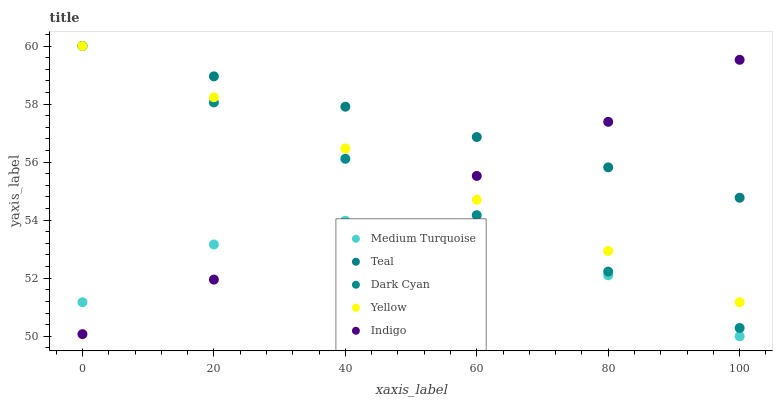Does Medium Turquoise have the minimum area under the curve?
Answer yes or no. Yes. Does Teal have the maximum area under the curve?
Answer yes or no. Yes. Does Indigo have the minimum area under the curve?
Answer yes or no. No. Does Indigo have the maximum area under the curve?
Answer yes or no. No. Is Yellow the smoothest?
Answer yes or no. Yes. Is Medium Turquoise the roughest?
Answer yes or no. Yes. Is Indigo the smoothest?
Answer yes or no. No. Is Indigo the roughest?
Answer yes or no. No. Does Medium Turquoise have the lowest value?
Answer yes or no. Yes. Does Indigo have the lowest value?
Answer yes or no. No. Does Teal have the highest value?
Answer yes or no. Yes. Does Indigo have the highest value?
Answer yes or no. No. Is Medium Turquoise less than Yellow?
Answer yes or no. Yes. Is Teal greater than Medium Turquoise?
Answer yes or no. Yes. Does Indigo intersect Dark Cyan?
Answer yes or no. Yes. Is Indigo less than Dark Cyan?
Answer yes or no. No. Is Indigo greater than Dark Cyan?
Answer yes or no. No. Does Medium Turquoise intersect Yellow?
Answer yes or no. No. 